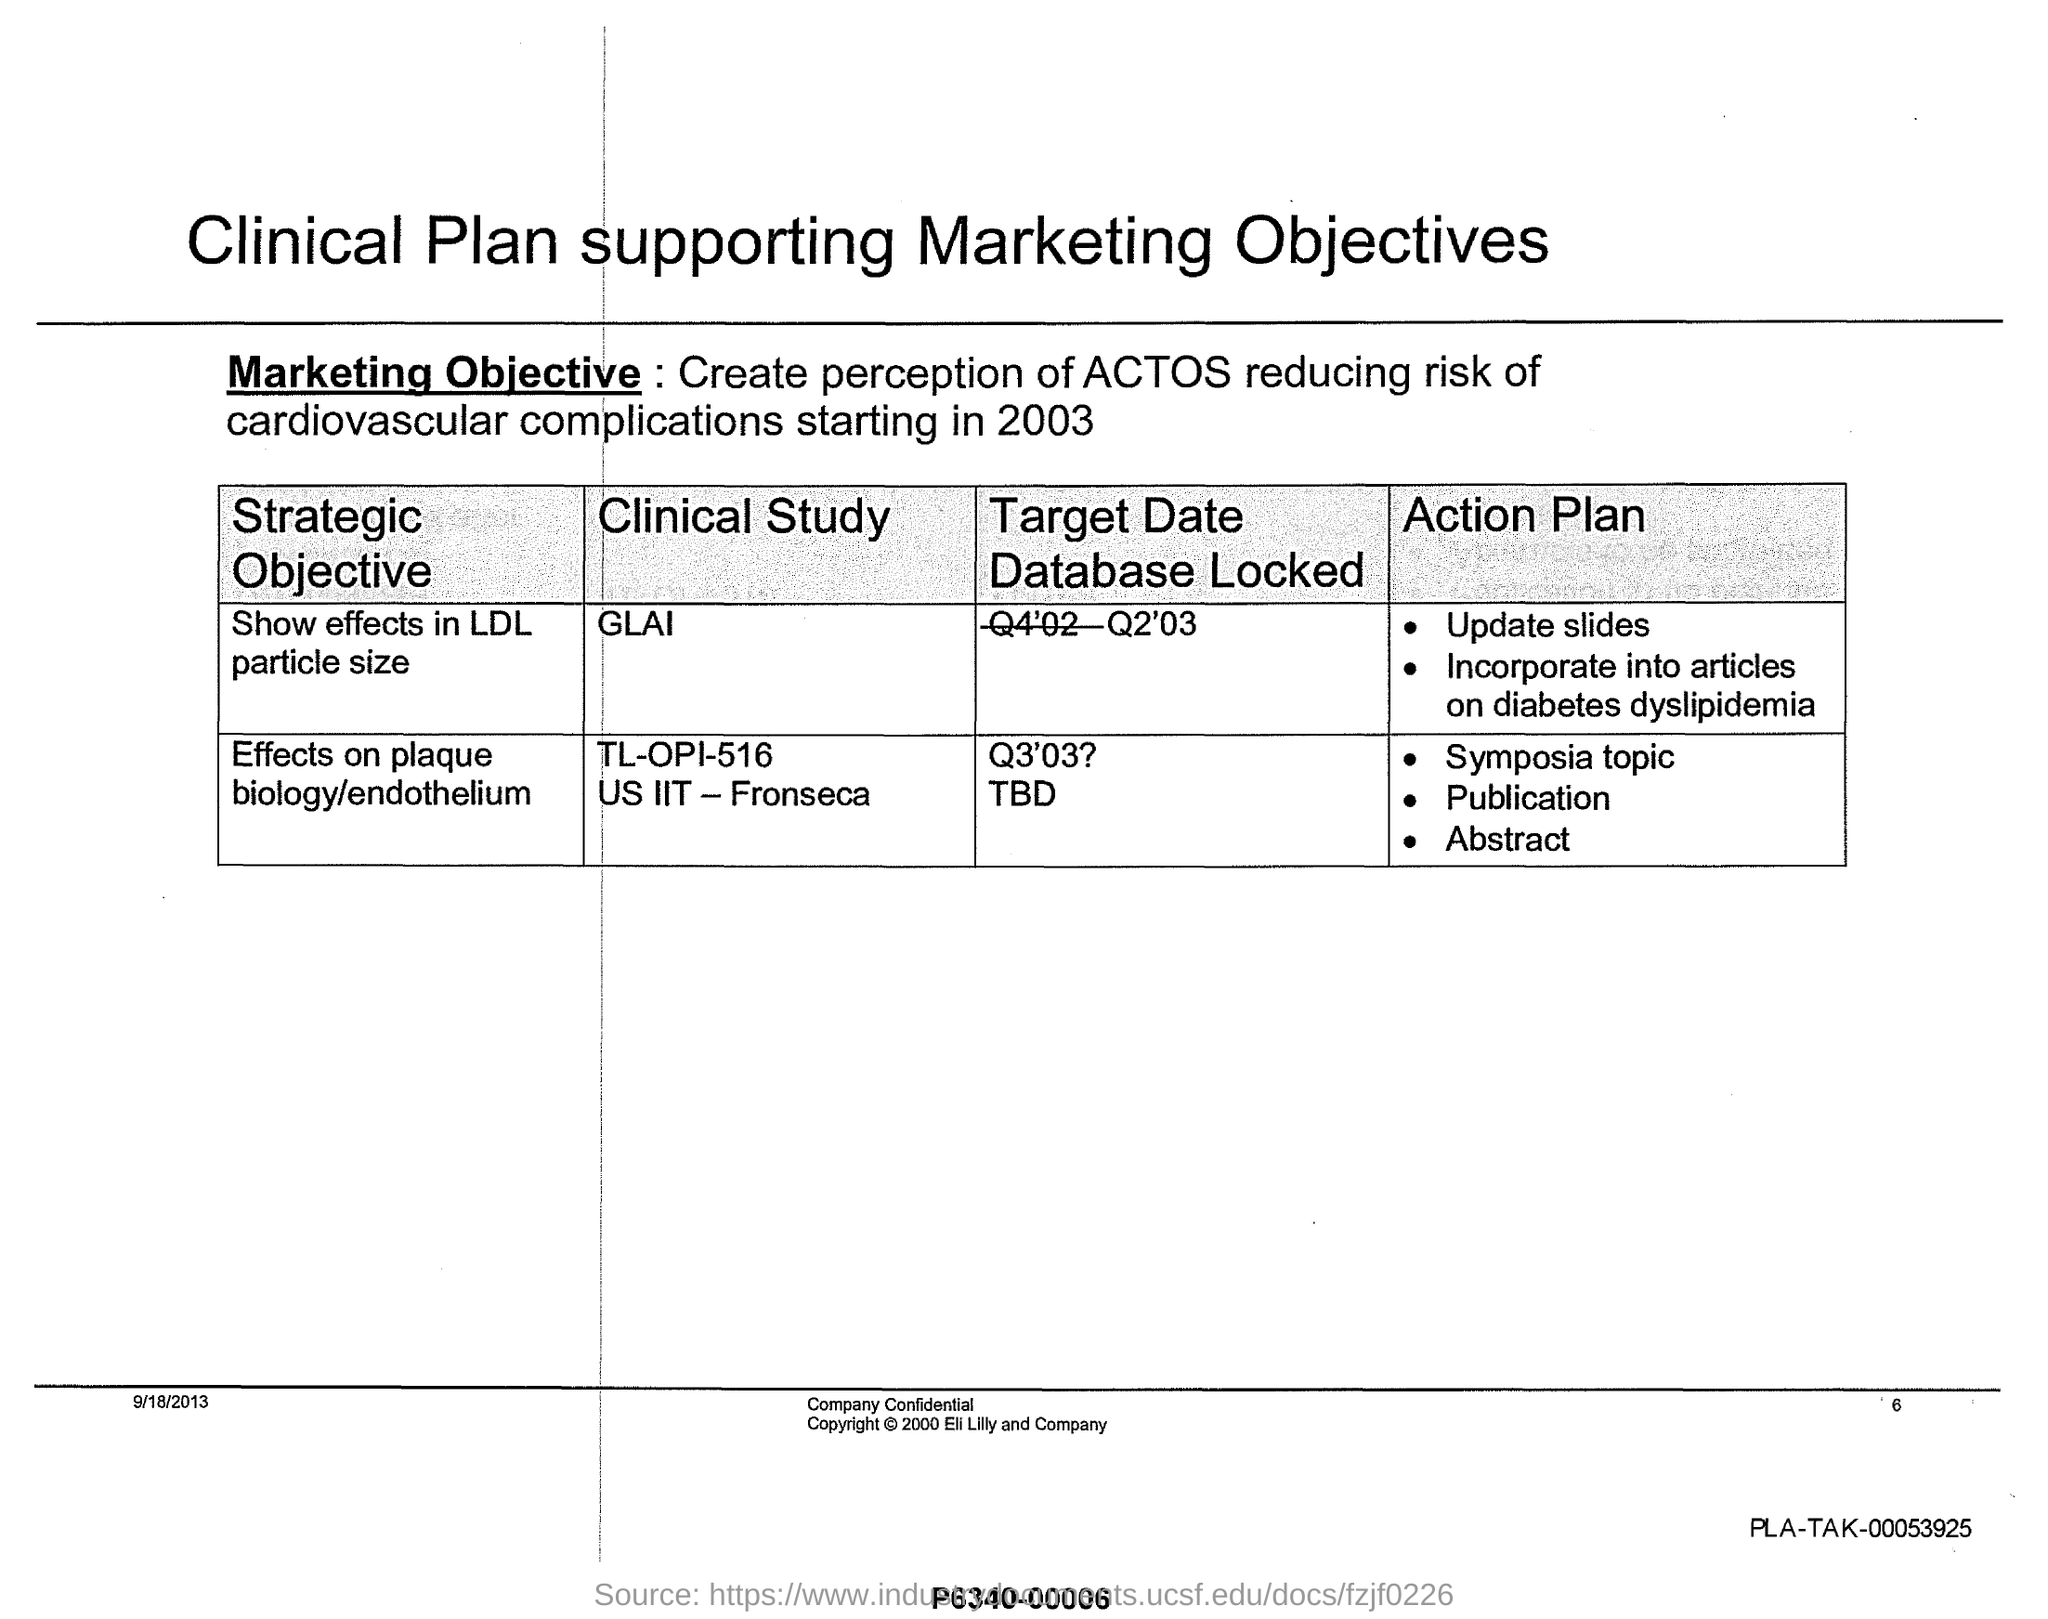Specify some key components in this picture. Eli Lilly and Company owns the copyright. The first Action Plan for the objective 'Effects on plaque biology/endothelium' is related to the Symposia topic. The title of the document is 'Clinical Plan Supporting Marketing Objectives.' The first strategic objective is to demonstrate the effects on LDL particle size. 